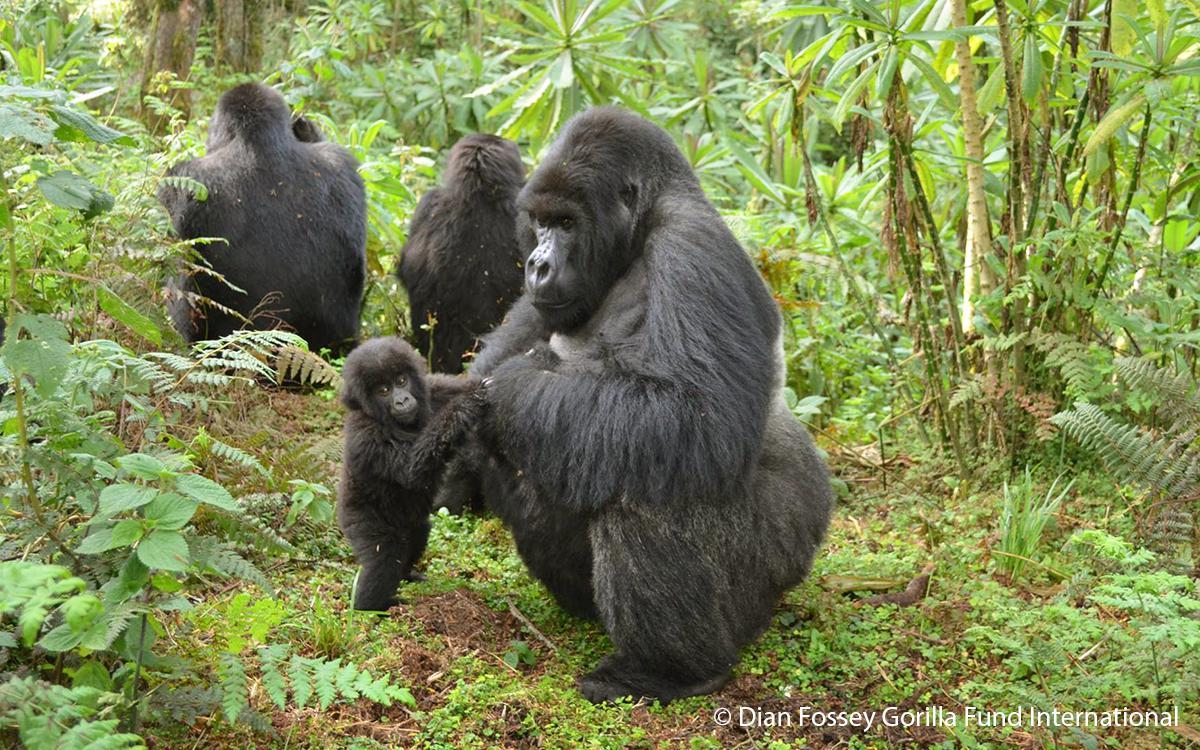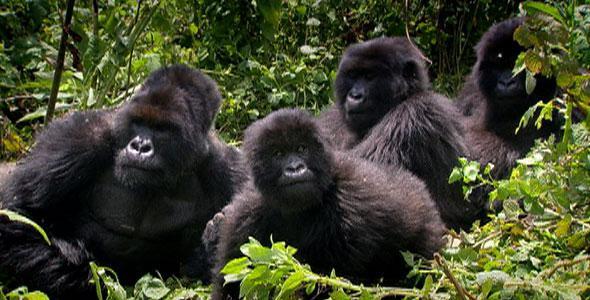The first image is the image on the left, the second image is the image on the right. Assess this claim about the two images: "There are more than two gorillas in each image.". Correct or not? Answer yes or no. Yes. 